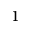Convert formula to latex. <formula><loc_0><loc_0><loc_500><loc_500>^ { 1 }</formula> 